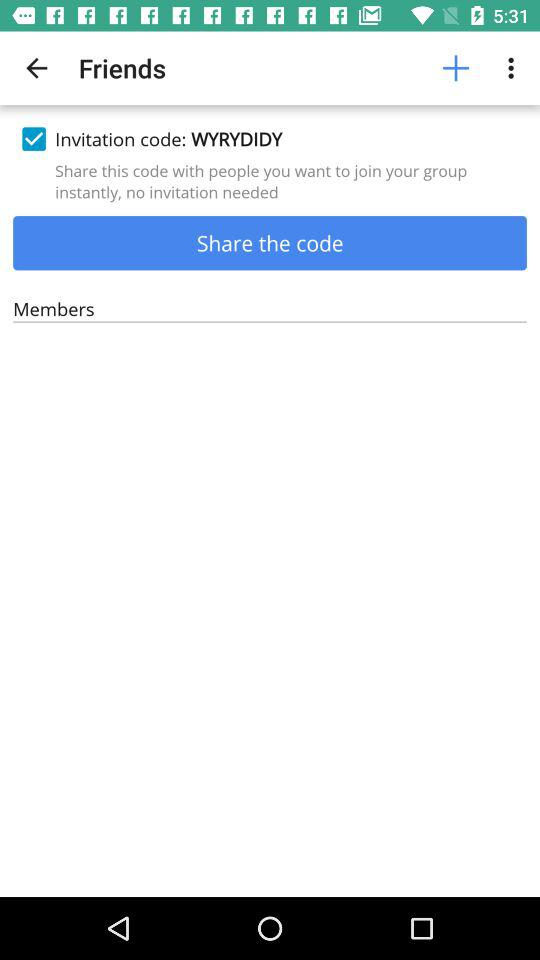What's the "Invitation code"? The code is "WYRYDIDY". 